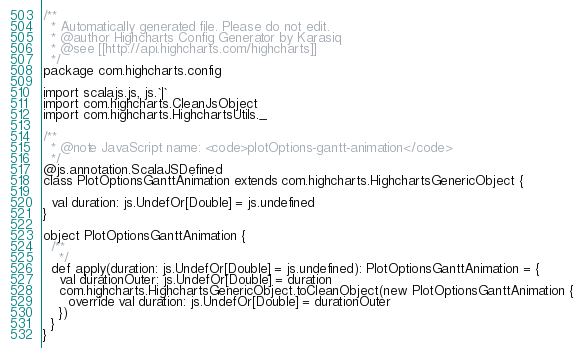<code> <loc_0><loc_0><loc_500><loc_500><_Scala_>/**
  * Automatically generated file. Please do not edit.
  * @author Highcharts Config Generator by Karasiq
  * @see [[http://api.highcharts.com/highcharts]]
  */
package com.highcharts.config

import scalajs.js, js.`|`
import com.highcharts.CleanJsObject
import com.highcharts.HighchartsUtils._

/**
  * @note JavaScript name: <code>plotOptions-gantt-animation</code>
  */
@js.annotation.ScalaJSDefined
class PlotOptionsGanttAnimation extends com.highcharts.HighchartsGenericObject {

  val duration: js.UndefOr[Double] = js.undefined
}

object PlotOptionsGanttAnimation {
  /**
    */
  def apply(duration: js.UndefOr[Double] = js.undefined): PlotOptionsGanttAnimation = {
    val durationOuter: js.UndefOr[Double] = duration
    com.highcharts.HighchartsGenericObject.toCleanObject(new PlotOptionsGanttAnimation {
      override val duration: js.UndefOr[Double] = durationOuter
    })
  }
}
</code> 